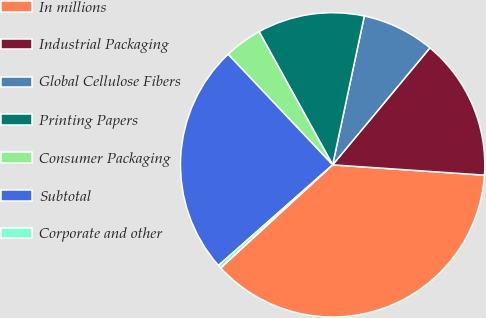Convert chart to OTSL. <chart><loc_0><loc_0><loc_500><loc_500><pie_chart><fcel>In millions<fcel>Industrial Packaging<fcel>Global Cellulose Fibers<fcel>Printing Papers<fcel>Consumer Packaging<fcel>Subtotal<fcel>Corporate and other<nl><fcel>37.08%<fcel>15.04%<fcel>7.7%<fcel>11.37%<fcel>4.02%<fcel>24.44%<fcel>0.35%<nl></chart> 